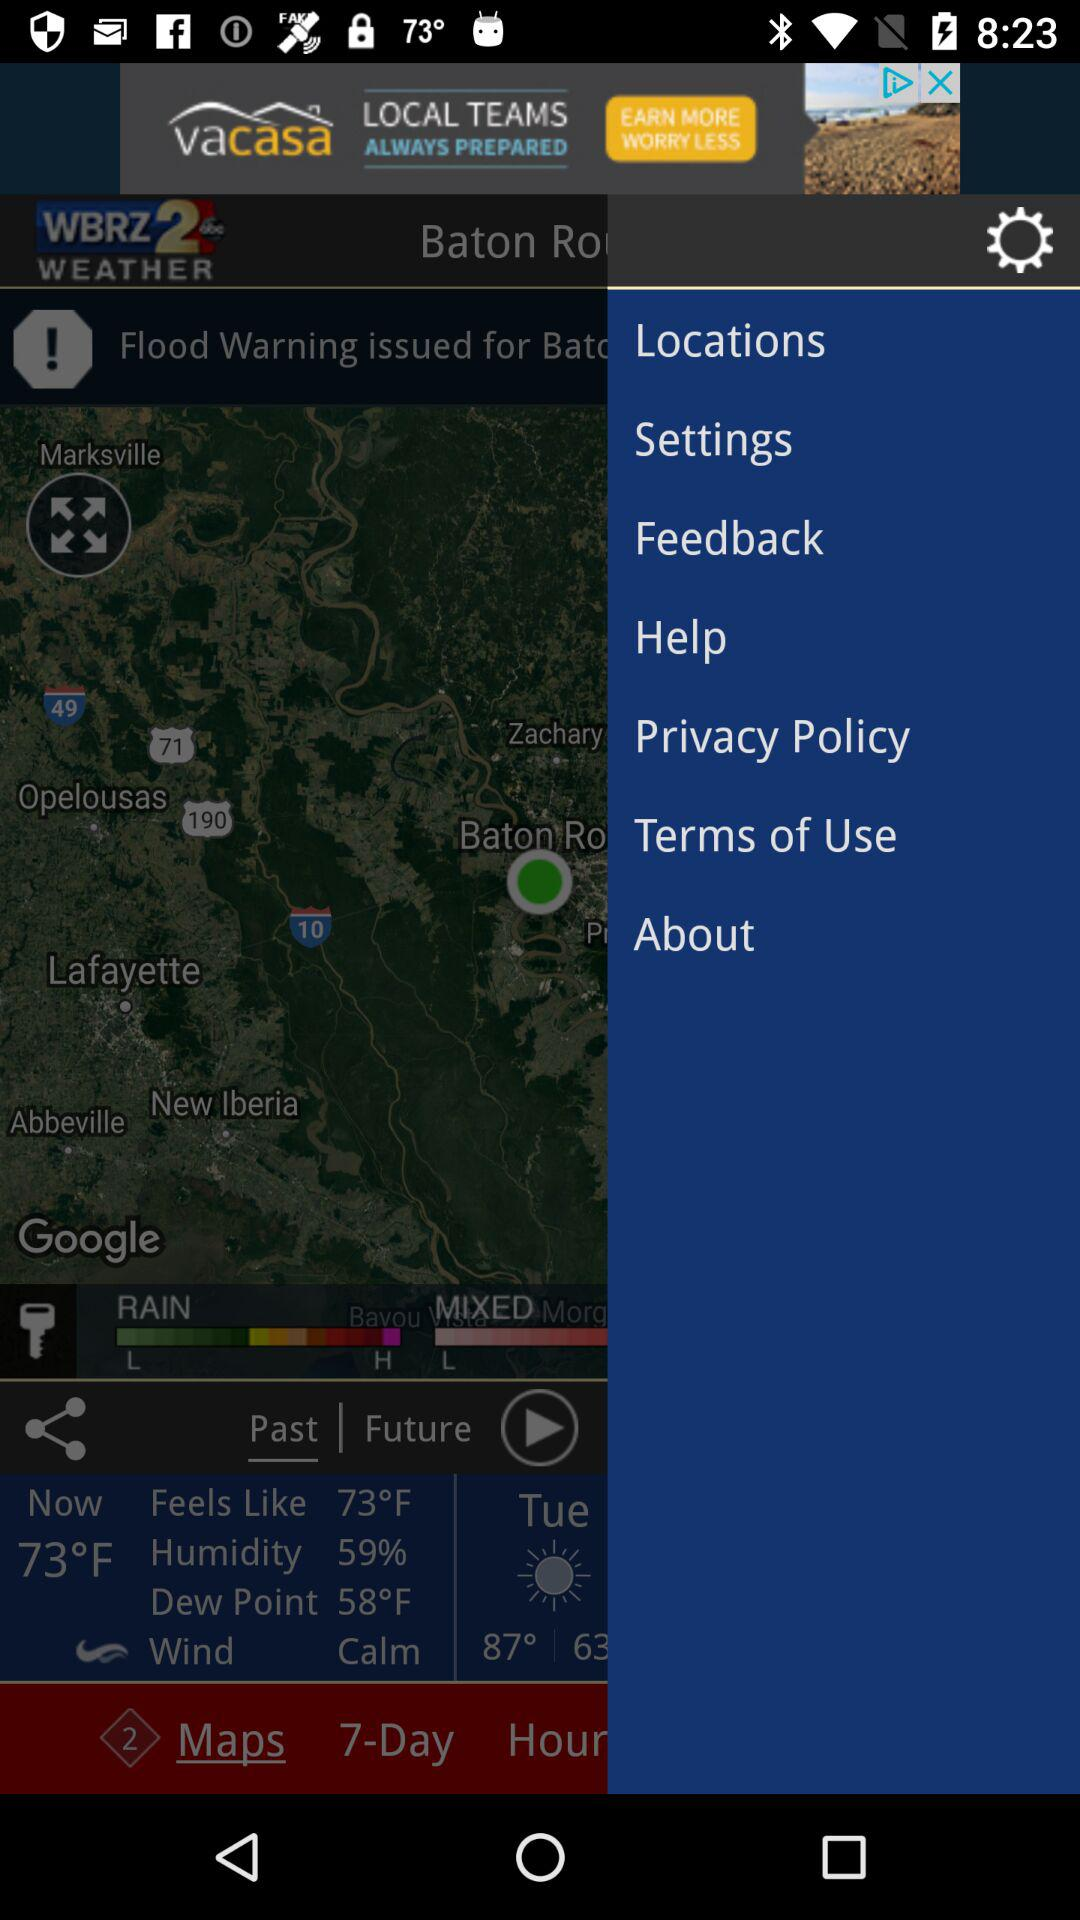How many degrees Fahrenheit is the temperature currently?
Answer the question using a single word or phrase. 73°F 